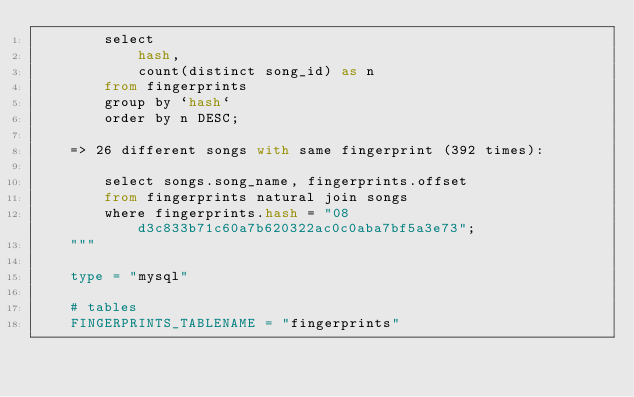Convert code to text. <code><loc_0><loc_0><loc_500><loc_500><_Python_>        select
            hash,
            count(distinct song_id) as n
        from fingerprints
        group by `hash`
        order by n DESC;

    => 26 different songs with same fingerprint (392 times):

        select songs.song_name, fingerprints.offset
        from fingerprints natural join songs
        where fingerprints.hash = "08d3c833b71c60a7b620322ac0c0aba7bf5a3e73";
    """

    type = "mysql"

    # tables
    FINGERPRINTS_TABLENAME = "fingerprints"</code> 